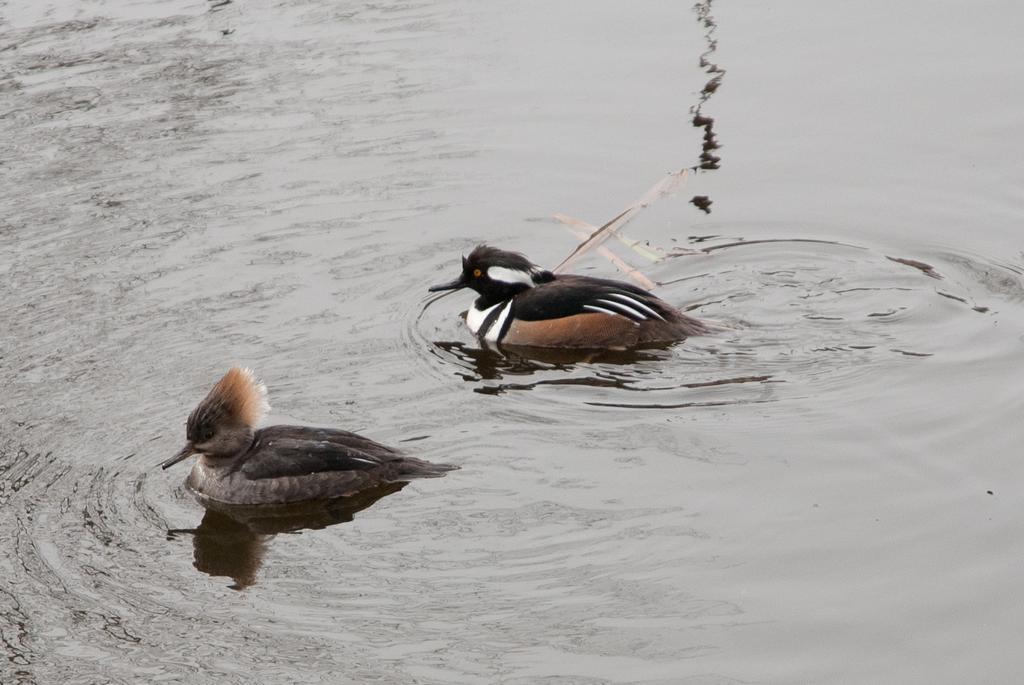Can you describe this image briefly? In this picture I can observe two birds swimming in the water. In the background I can observe water. 